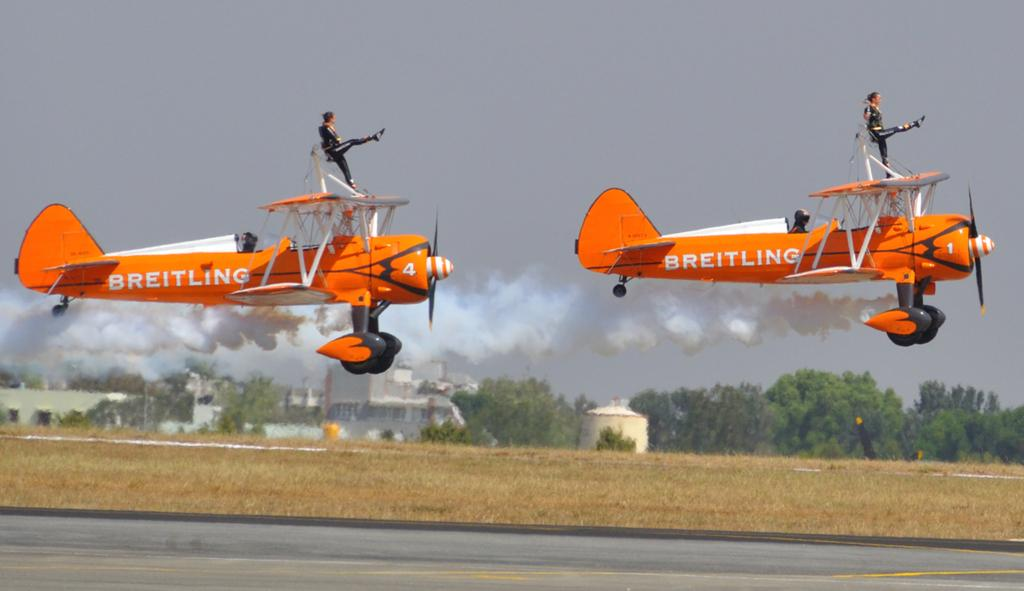<image>
Write a terse but informative summary of the picture. Two small orange and white Breitling planes taking off on a runway. 